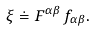<formula> <loc_0><loc_0><loc_500><loc_500>\xi \doteq F ^ { \alpha \beta } \, f _ { \alpha \beta } .</formula> 